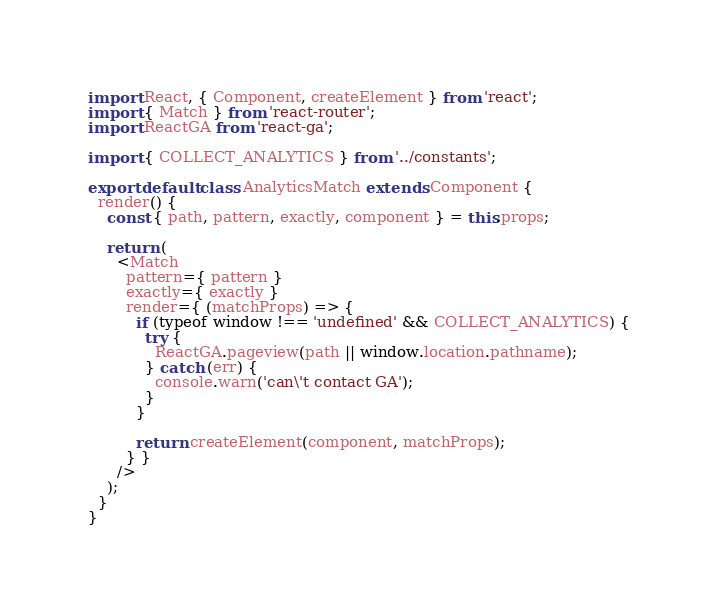<code> <loc_0><loc_0><loc_500><loc_500><_JavaScript_>import React, { Component, createElement } from 'react';
import { Match } from 'react-router';
import ReactGA from 'react-ga';

import { COLLECT_ANALYTICS } from '../constants';

export default class AnalyticsMatch extends Component {
  render() {
    const { path, pattern, exactly, component } = this.props;

    return (
      <Match
        pattern={ pattern }
        exactly={ exactly }
        render={ (matchProps) => {
          if (typeof window !== 'undefined' && COLLECT_ANALYTICS) {
            try {
              ReactGA.pageview(path || window.location.pathname);
            } catch (err) {
              console.warn('can\'t contact GA');
            }
          }

          return createElement(component, matchProps);
        } }
      />
    );
  }
}
</code> 